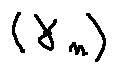<formula> <loc_0><loc_0><loc_500><loc_500>( \gamma _ { n } )</formula> 